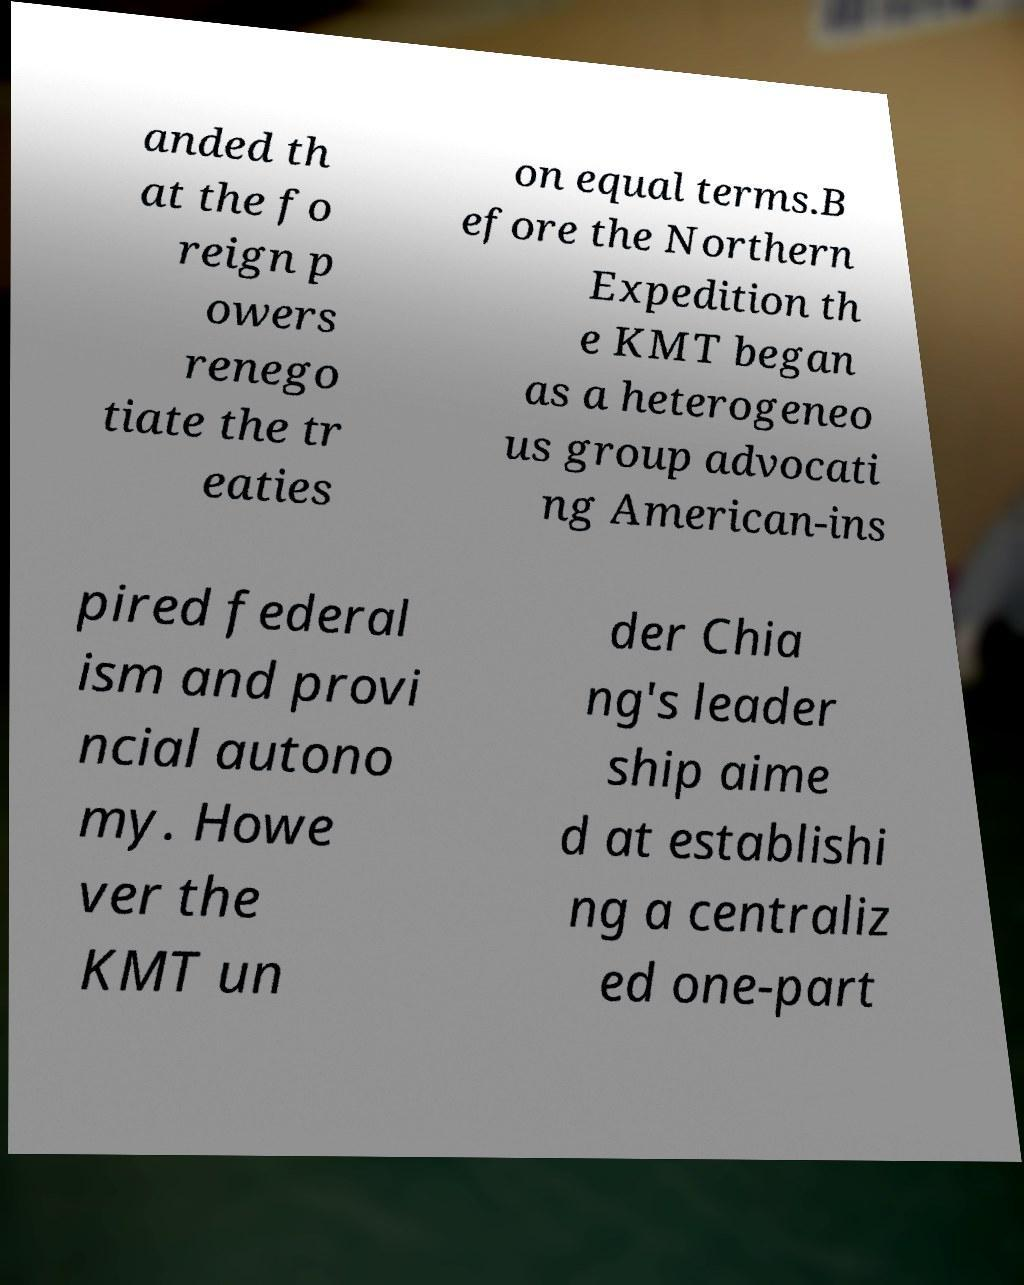Please identify and transcribe the text found in this image. anded th at the fo reign p owers renego tiate the tr eaties on equal terms.B efore the Northern Expedition th e KMT began as a heterogeneo us group advocati ng American-ins pired federal ism and provi ncial autono my. Howe ver the KMT un der Chia ng's leader ship aime d at establishi ng a centraliz ed one-part 